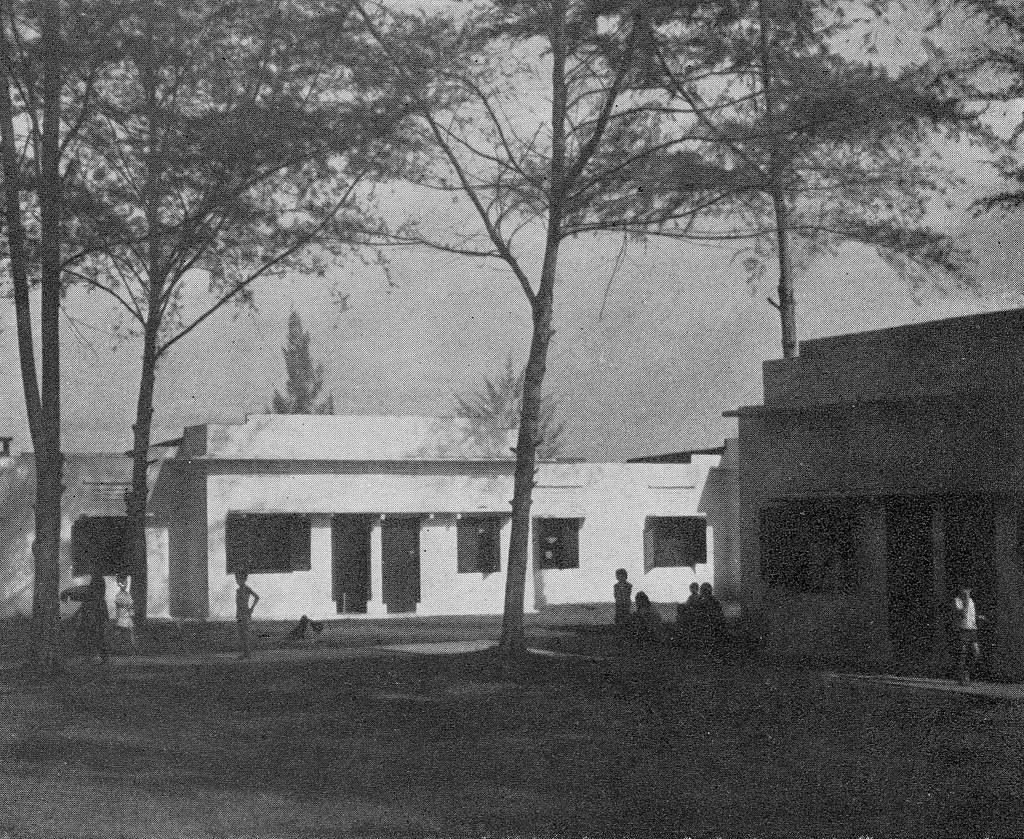What type of structures can be seen in the image? There are houses in the image. What feature do the houses have? The houses have windows. Who or what else is visible in the image? There are people visible in the image. What type of natural elements can be seen in the image? There are trees in the image. What part of the environment is visible in the image? The sky is visible in the image. How would you describe the lighting in the image? The image appears to be slightly dark. What type of brain activity can be observed in the image? There is no brain present in the image, so it is not possible to observe brain activity. 